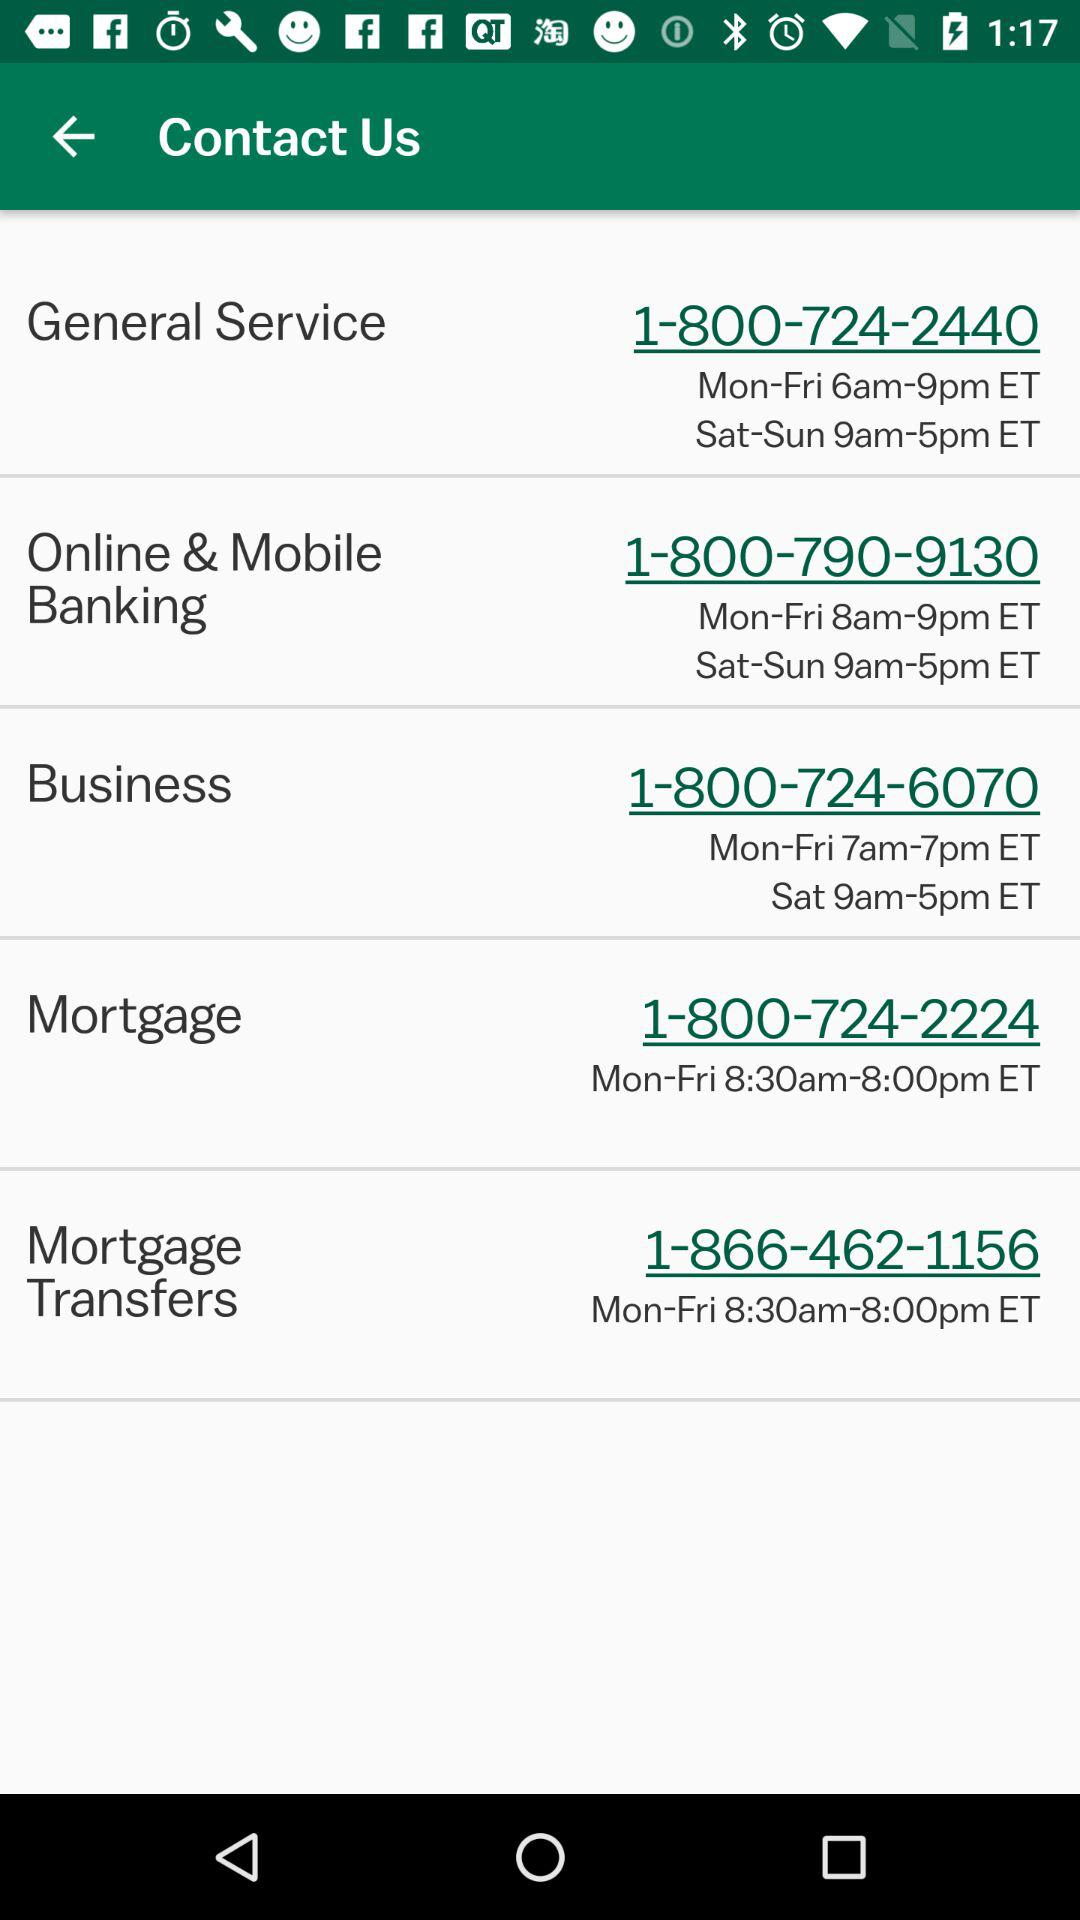What is the time to talk on Saturday and Sunday for "Online & Mobile Banking"? The time to talk on Saturday and Sunday for "Online & Mobile Banking" is 9am to 5pm ET. 